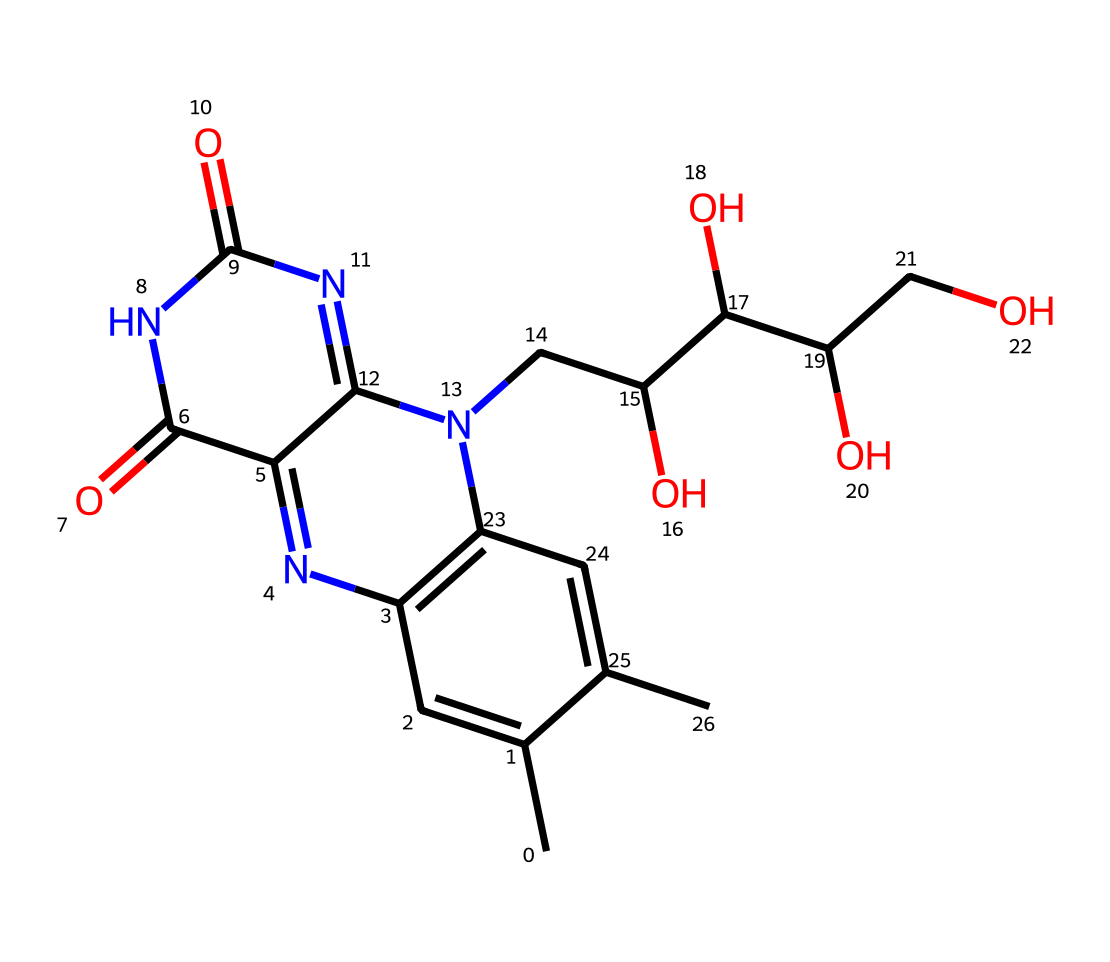What is the molecular formula of riboflavin? To determine the molecular formula, count the number of each type of atom present in the provided SMILES representation, which includes carbon (C), hydrogen (H), nitrogen (N), and oxygen (O). By analyzing the structure, we find there are 17 carbons, 21 hydrogens, 3 nitrogens, and 6 oxygens. This leads us to the molecular formula C17H21N3O6.
Answer: C17H21N3O6 How many rings are present in the riboflavin structure? By examining the chemical structure represented by the SMILES, we can identify that there are two distinct aromatic rings. One ring system is clearly visible with alternating double bonds, and another is fused to a nitrogen-containing ring. Therefore, there are 2 rings in total.
Answer: 2 What type of compound is riboflavin? Looking at the structure, riboflavin contains nitrogen atoms in its rings and has a functional group that includes a ribityl side chain, indicating that it is a vitamin and specifically a B vitamin. This classification allows us to conclude that riboflavin is a vitamin.
Answer: vitamin Which element in riboflavin contributes to its nitrogenous characteristics? The nitrogen atoms present in the structure, specifically those in the ring systems, are responsible for these nitrogenous characteristics, allowing riboflavin to be classified as a nitrogen-containing compound. Therefore, the element that contributes to this is nitrogen.
Answer: nitrogen What functional groups are present in riboflavin? By analyzing the structure for specific functional groups, we can identify hydroxyl (-OH) groups in the ribityl side chain and carbonyl (=O) groups in the ring structure. These functional groups are characteristic of riboflavin. Thus, the identifiable functional groups include hydroxyl and carbonyl.
Answer: hydroxyl, carbonyl How many total heteroatoms are found in the riboflavin structure? Identifying heteroatoms involves counting atoms that are not carbon or hydrogen; in this case, the heteroatoms are nitrogen (3) and oxygen (6). Adding these together gives us a total of 9 heteroatoms.
Answer: 9 